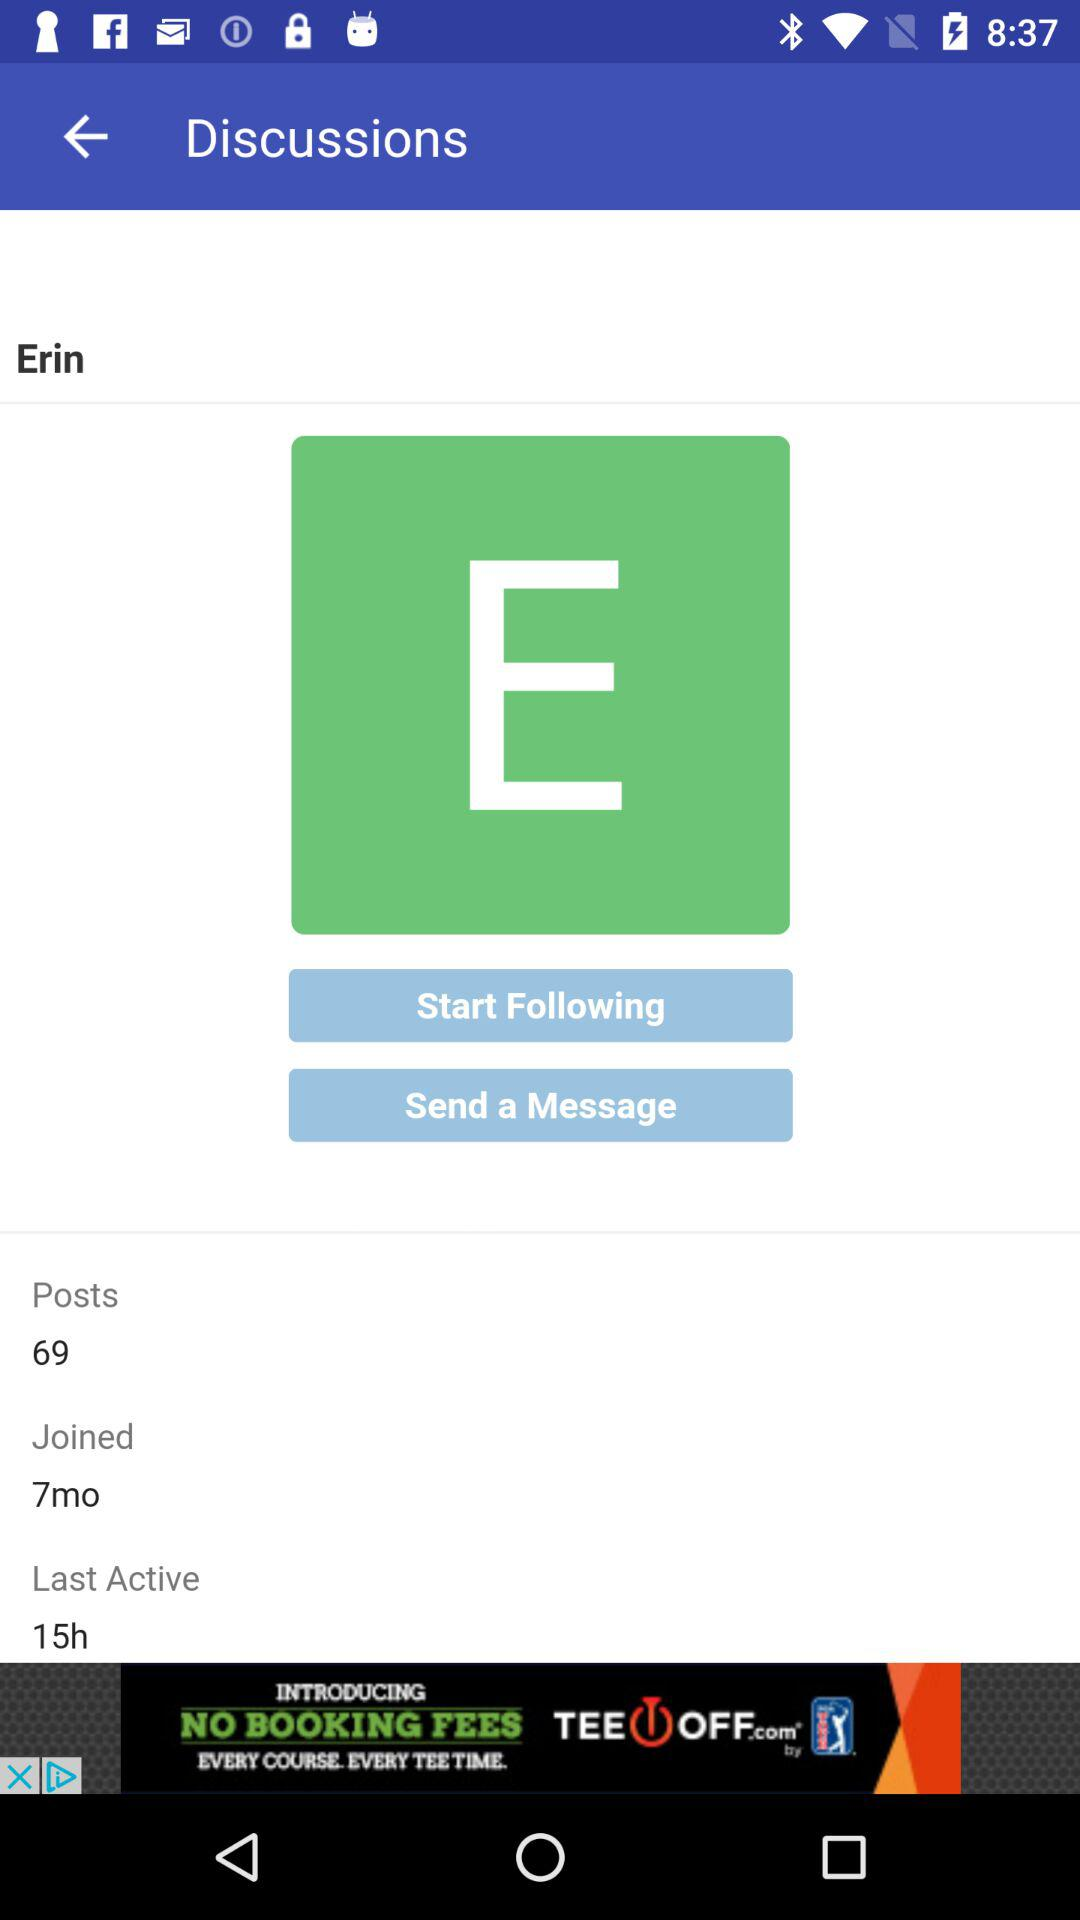How many more posts does Erin have than joined months?
Answer the question using a single word or phrase. 62 